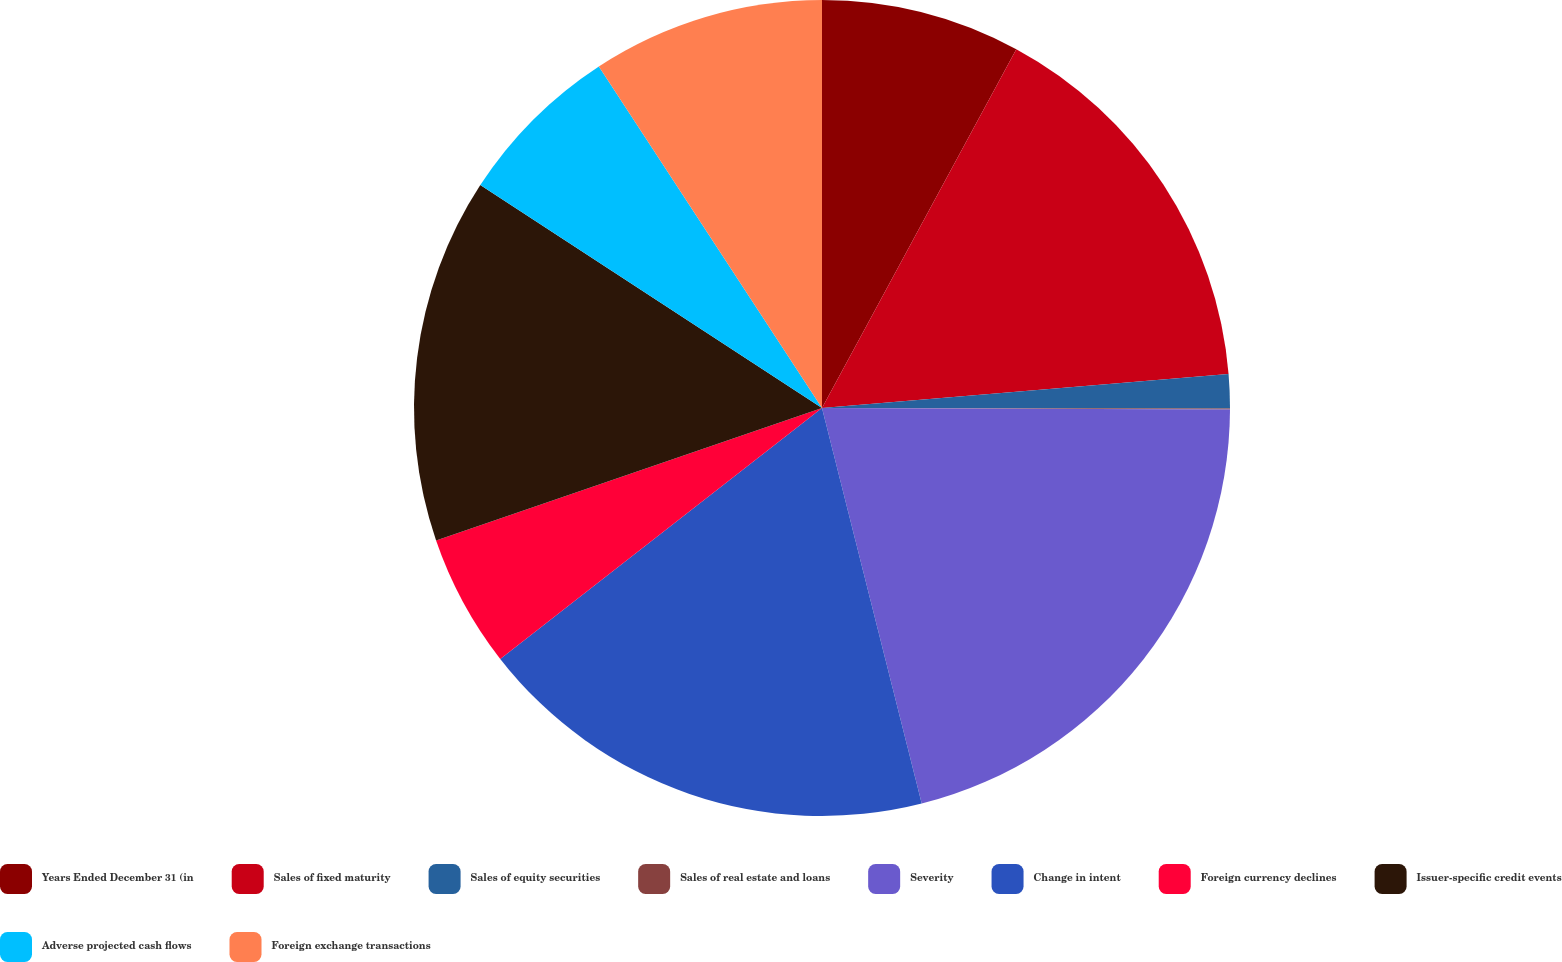Convert chart to OTSL. <chart><loc_0><loc_0><loc_500><loc_500><pie_chart><fcel>Years Ended December 31 (in<fcel>Sales of fixed maturity<fcel>Sales of equity securities<fcel>Sales of real estate and loans<fcel>Severity<fcel>Change in intent<fcel>Foreign currency declines<fcel>Issuer-specific credit events<fcel>Adverse projected cash flows<fcel>Foreign exchange transactions<nl><fcel>7.9%<fcel>15.77%<fcel>1.35%<fcel>0.04%<fcel>21.01%<fcel>18.39%<fcel>5.28%<fcel>14.46%<fcel>6.59%<fcel>9.21%<nl></chart> 